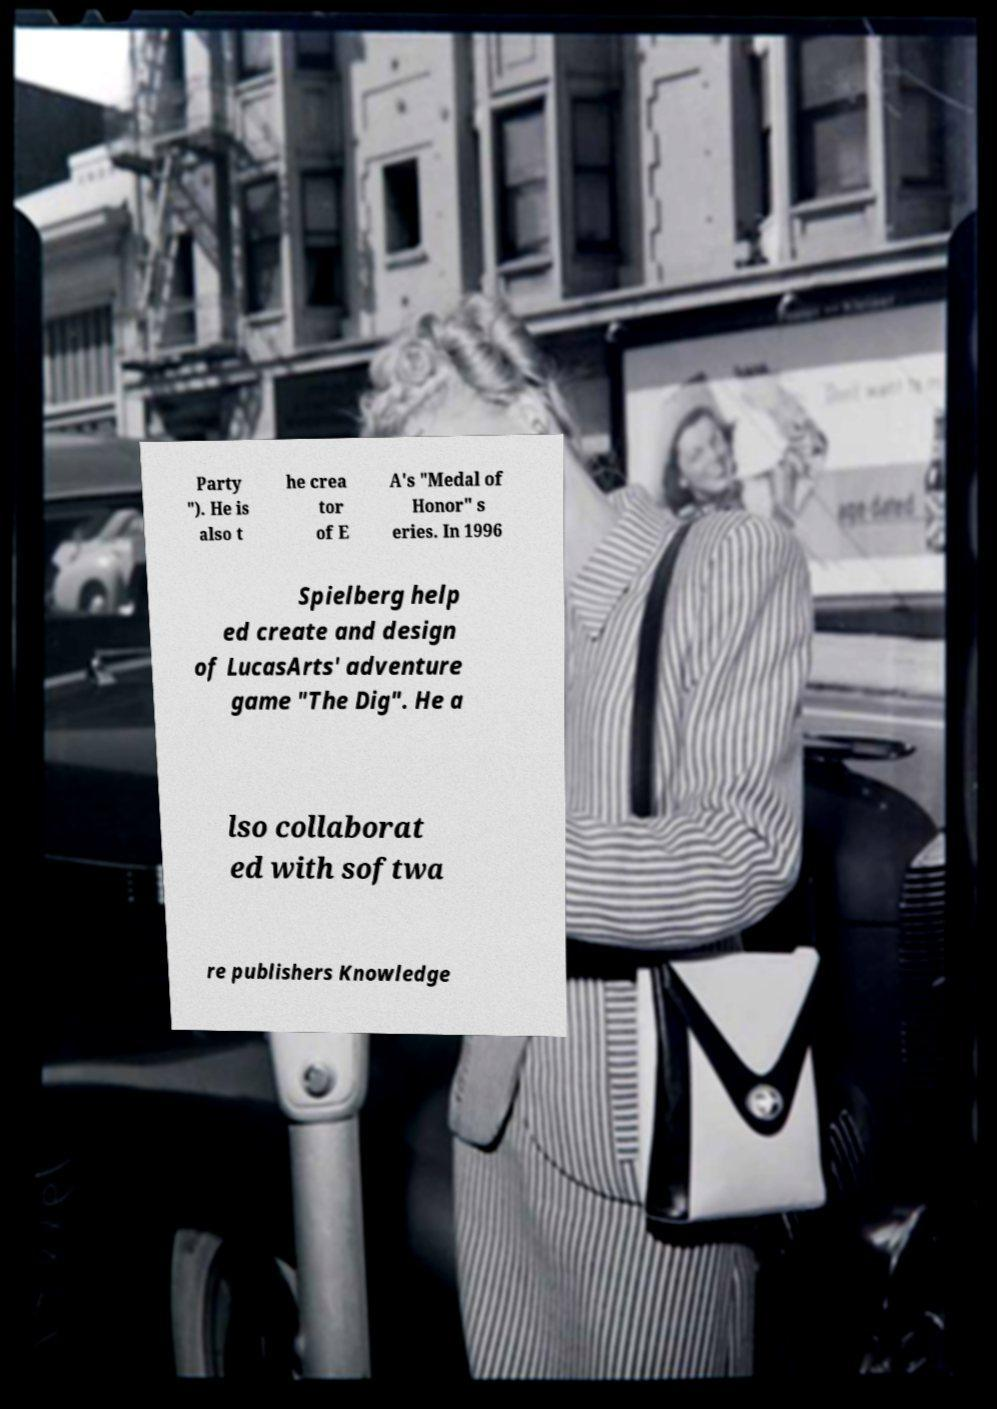Can you read and provide the text displayed in the image?This photo seems to have some interesting text. Can you extract and type it out for me? Party "). He is also t he crea tor of E A's "Medal of Honor" s eries. In 1996 Spielberg help ed create and design of LucasArts' adventure game "The Dig". He a lso collaborat ed with softwa re publishers Knowledge 